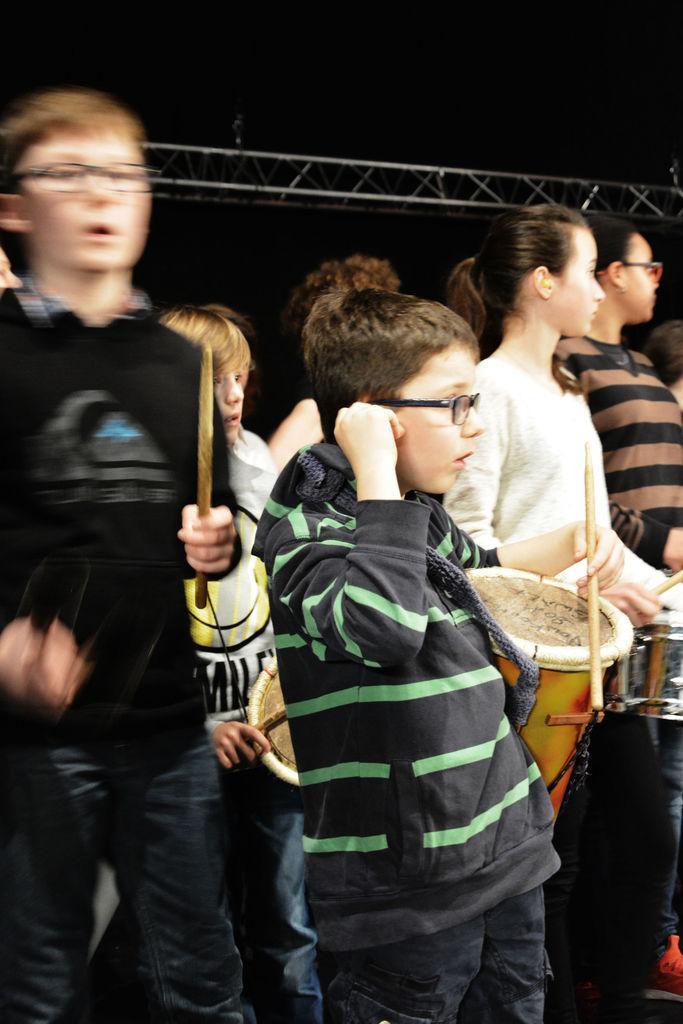In one or two sentences, can you explain what this image depicts? Here we can see a group of children standing and there are some children who are playing drums 